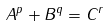<formula> <loc_0><loc_0><loc_500><loc_500>A ^ { p } + B ^ { q } = C ^ { r }</formula> 